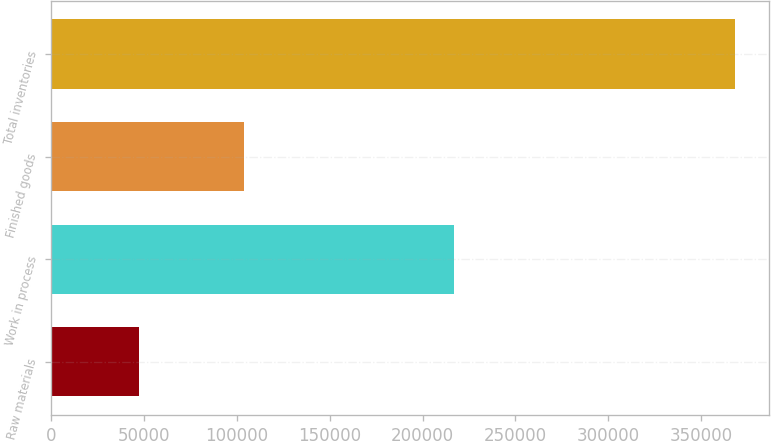<chart> <loc_0><loc_0><loc_500><loc_500><bar_chart><fcel>Raw materials<fcel>Work in process<fcel>Finished goods<fcel>Total inventories<nl><fcel>47267<fcel>216765<fcel>103895<fcel>367927<nl></chart> 